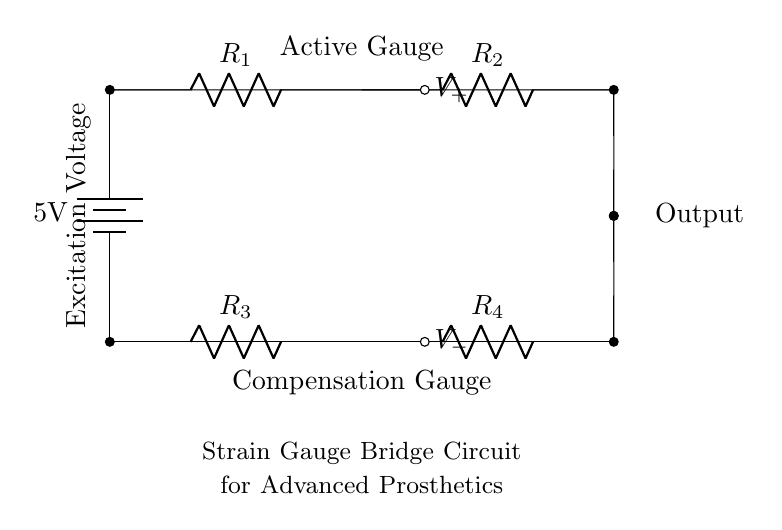What is the excitation voltage in this circuit? The excitation voltage is the voltage provided by the battery, which is indicated directly on the diagram. It shows a battery with a label of 5V.
Answer: 5V What type of components are R1, R2, R3, and R4? These components are all resistors, as denoted by the symbol 'R' followed by their respective identifiers. The circuit indicates four resistors in total.
Answer: Resistors What do the nodes labeled V+ and V- represent? V+ and V- are the output voltages from the strain gauge bridge circuit. V+ is taken from the upper node, and V- is taken from the lower node, representing the differential output.
Answer: Output voltages Which resistors function as the active and compensation gauges? R1 is the active gauge, while R4 serves as the compensation gauge, as indicated by their labels in the circuit diagram. This distinction allows the circuit to account for temperature and other variations effectively.
Answer: R1 and R4 How many resistors are part of this strain gauge bridge circuit? The circuit clearly shows a total of four resistors connected in a bridge configuration. Counting each resistor from the diagram confirms this number.
Answer: Four resistors What is the purpose of the strain gauge bridge circuit in advanced prosthetics? The primary purpose of this circuit is to detect minute muscle movements, enabling the prosthetics to respond to user intentions based on the small changes in resistance in the strain gauges.
Answer: Detect muscle movements What does the term "bridge" refer to in this circuit? The term "bridge" refers to the specific configuration of resistors arranged in a way that allows for the measurement of small changes in resistance due to strain or pressure, enabling precision in detecting outputs.
Answer: Configuration of resistors 